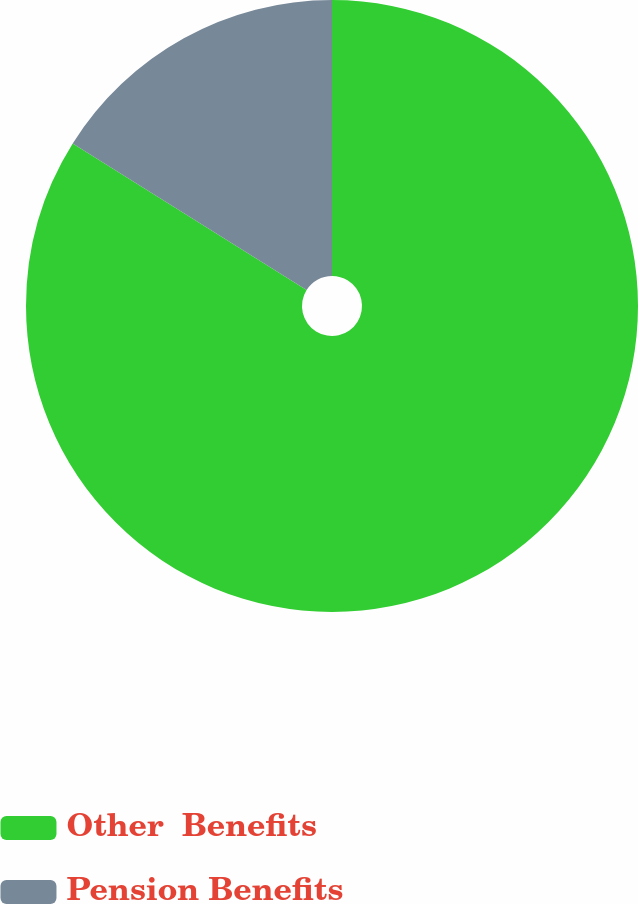Convert chart to OTSL. <chart><loc_0><loc_0><loc_500><loc_500><pie_chart><fcel>Other  Benefits<fcel>Pension Benefits<nl><fcel>83.91%<fcel>16.09%<nl></chart> 